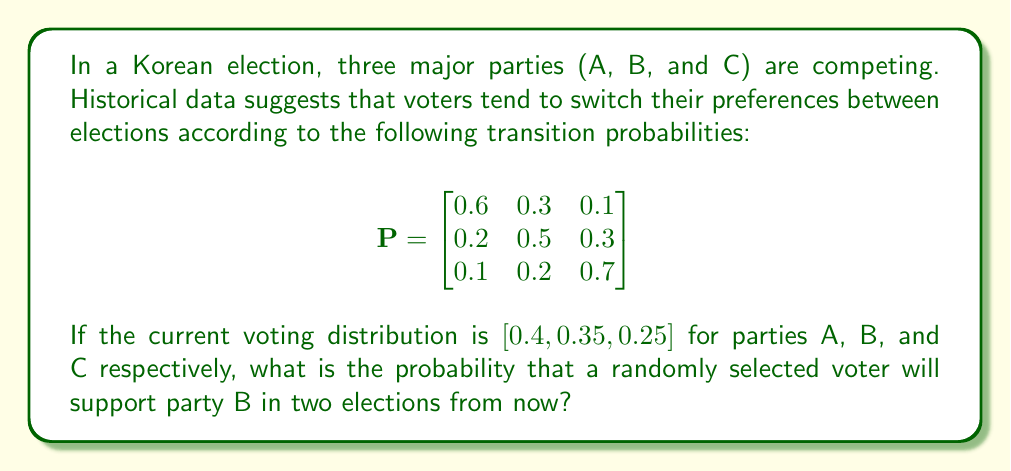Can you solve this math problem? To solve this problem, we'll use Markov chains to predict the voting distribution after two elections:

1. Let $\pi_0 = [0.4, 0.35, 0.25]$ be the initial distribution vector.

2. To find the distribution after two elections, we need to multiply $\pi_0$ by $P^2$:
   
   $\pi_2 = \pi_0 P^2$

3. First, calculate $P^2$:
   
   $$P^2 = \begin{bmatrix}
   0.6 & 0.3 & 0.1 \\
   0.2 & 0.5 & 0.3 \\
   0.1 & 0.2 & 0.7
   \end{bmatrix} \times 
   \begin{bmatrix}
   0.6 & 0.3 & 0.1 \\
   0.2 & 0.5 & 0.3 \\
   0.1 & 0.2 & 0.7
   \end{bmatrix}$$

   $$P^2 = \begin{bmatrix}
   0.42 & 0.36 & 0.22 \\
   0.27 & 0.41 & 0.32 \\
   0.16 & 0.27 & 0.57
   \end{bmatrix}$$

4. Now, multiply $\pi_0$ by $P^2$:
   
   $\pi_2 = [0.4, 0.35, 0.25] \times 
   \begin{bmatrix}
   0.42 & 0.36 & 0.22 \\
   0.27 & 0.41 & 0.32 \\
   0.16 & 0.27 & 0.57
   \end{bmatrix}$

5. Perform the matrix multiplication:
   
   $\pi_2 = [0.3145, 0.3585, 0.3270]$

6. The probability of supporting party B in two elections from now is the second element of $\pi_2$, which is 0.3585 or approximately 35.85%.
Answer: 0.3585 